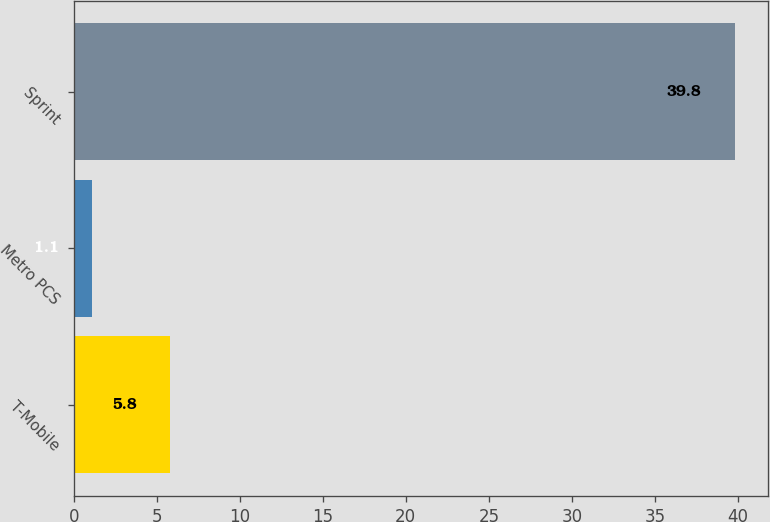Convert chart to OTSL. <chart><loc_0><loc_0><loc_500><loc_500><bar_chart><fcel>T-Mobile<fcel>Metro PCS<fcel>Sprint<nl><fcel>5.8<fcel>1.1<fcel>39.8<nl></chart> 